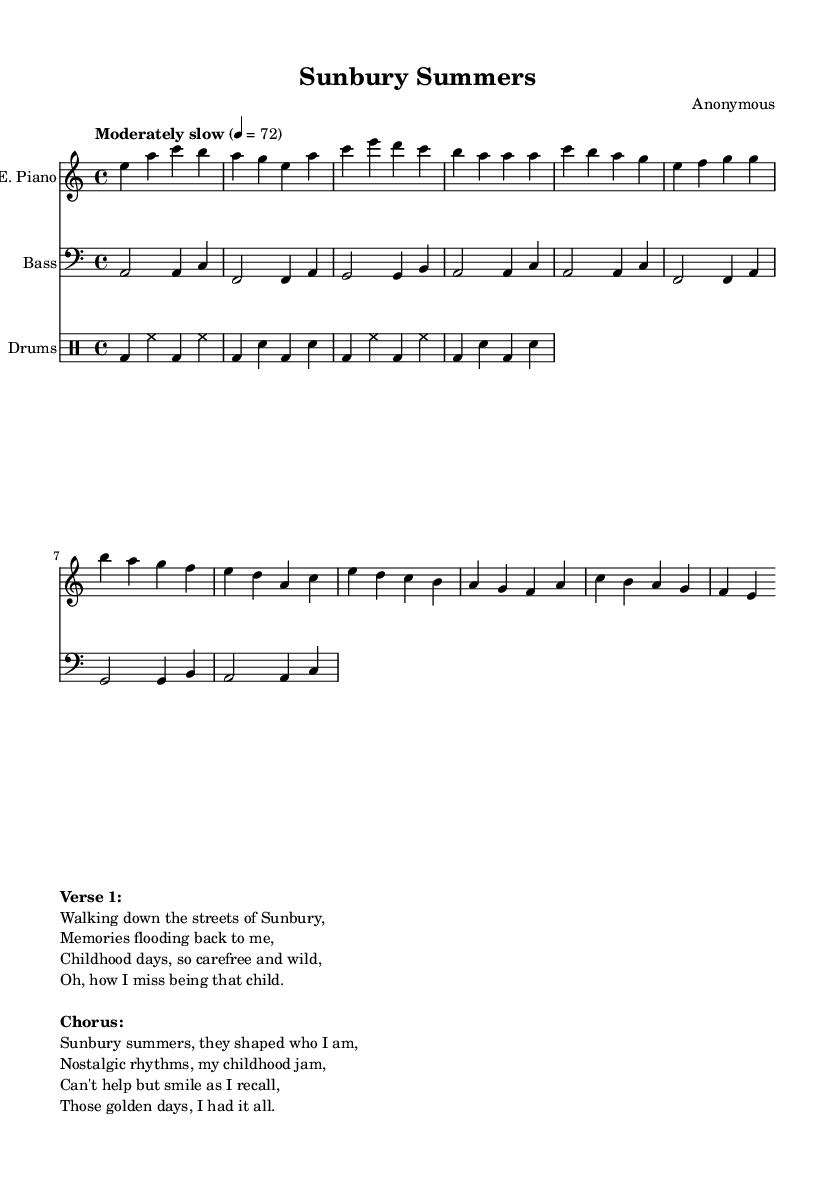What is the key signature of this music? The key signature is indicated by the number of sharps or flats at the beginning of the staff. In this case, there are no sharps or flats, which means it is in A minor.
Answer: A minor What is the time signature of the piece? The time signature appears at the beginning of the sheet music, represented as two numbers. Here, it shows 4/4, meaning there are four beats in each measure and the quarter note gets one beat.
Answer: 4/4 What is the tempo marking for this piece? Tempo markings are typically indicated above the staff. In this case, it shows "Moderately slow" with a number indicating beats per minute (BPM). Here, it indicates a tempo of 72 beats per minute.
Answer: 72 How many measures are in the electric piano part? Measures are divided by vertical lines on the staff. By counting the sections between these vertical lines in the electric piano part, we find there are 8 measures.
Answer: 8 What is the primary mood conveyed by the lyrics? The mood can be inferred by analyzing the context and wording in the lyrics. Here, the lyrics evoke nostalgia and a sense of longing for carefree childhood days in Sunbury, which indicates a reflective and sentimental mood.
Answer: Nostalgic What is the primary instrument used in this piece? The primary instrument can be determined by looking at the first staff in the score. The electric piano is labeled with "E. Piano," indicating it is the main instrument featured in the arrangement.
Answer: E. Piano 